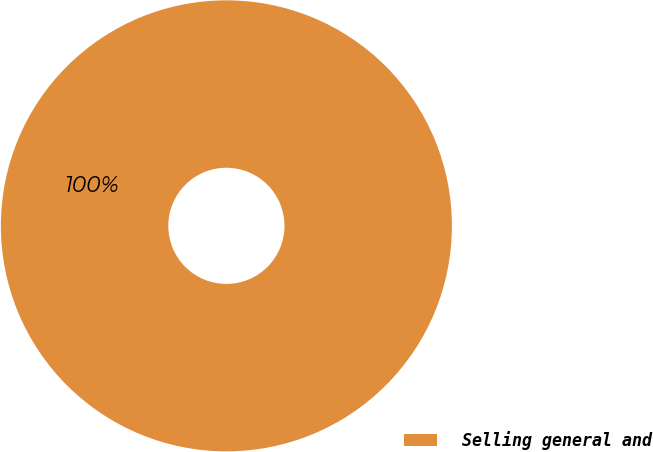Convert chart. <chart><loc_0><loc_0><loc_500><loc_500><pie_chart><fcel>Selling general and<nl><fcel>100.0%<nl></chart> 